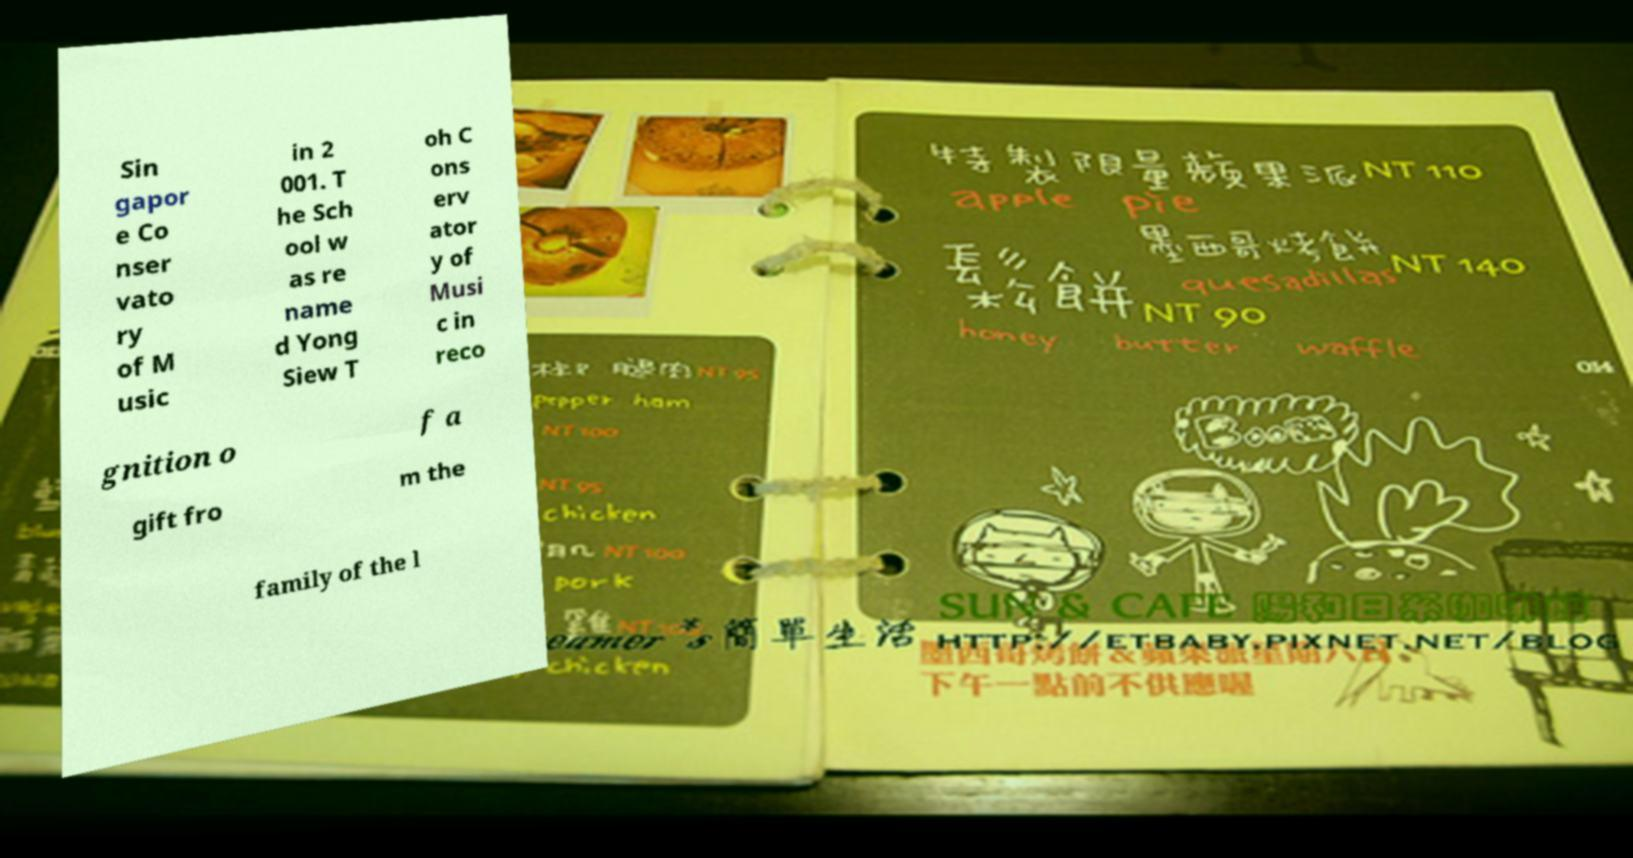Please read and relay the text visible in this image. What does it say? Sin gapor e Co nser vato ry of M usic in 2 001. T he Sch ool w as re name d Yong Siew T oh C ons erv ator y of Musi c in reco gnition o f a gift fro m the family of the l 